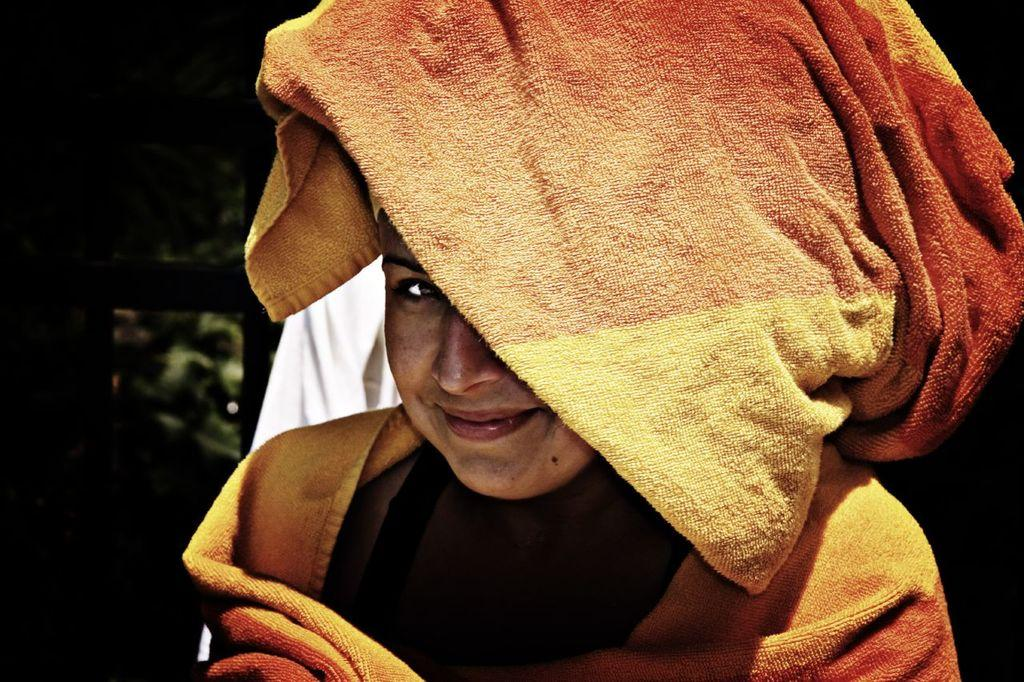What is the main subject of the image? There is a person in the image. What is the person holding in the image? The person is holding a cloth. Can you describe the cloth behind the person? There is a white color cloth behind the person. How would you describe the overall lighting in the image? The background of the image is dark. How many leaves are on the person's head in the image? There are no leaves present in the image; the person is holding a cloth. 